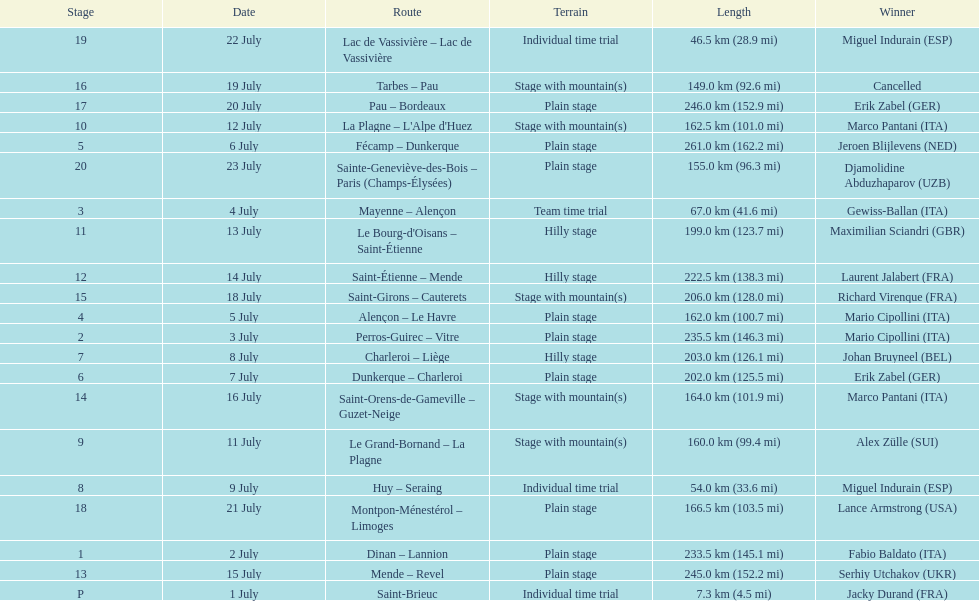How many routes have below 100 km total? 4. Parse the table in full. {'header': ['Stage', 'Date', 'Route', 'Terrain', 'Length', 'Winner'], 'rows': [['19', '22 July', 'Lac de Vassivière – Lac de Vassivière', 'Individual time trial', '46.5\xa0km (28.9\xa0mi)', 'Miguel Indurain\xa0(ESP)'], ['16', '19 July', 'Tarbes – Pau', 'Stage with mountain(s)', '149.0\xa0km (92.6\xa0mi)', 'Cancelled'], ['17', '20 July', 'Pau – Bordeaux', 'Plain stage', '246.0\xa0km (152.9\xa0mi)', 'Erik Zabel\xa0(GER)'], ['10', '12 July', "La Plagne – L'Alpe d'Huez", 'Stage with mountain(s)', '162.5\xa0km (101.0\xa0mi)', 'Marco Pantani\xa0(ITA)'], ['5', '6 July', 'Fécamp – Dunkerque', 'Plain stage', '261.0\xa0km (162.2\xa0mi)', 'Jeroen Blijlevens\xa0(NED)'], ['20', '23 July', 'Sainte-Geneviève-des-Bois – Paris (Champs-Élysées)', 'Plain stage', '155.0\xa0km (96.3\xa0mi)', 'Djamolidine Abduzhaparov\xa0(UZB)'], ['3', '4 July', 'Mayenne – Alençon', 'Team time trial', '67.0\xa0km (41.6\xa0mi)', 'Gewiss-Ballan\xa0(ITA)'], ['11', '13 July', "Le Bourg-d'Oisans – Saint-Étienne", 'Hilly stage', '199.0\xa0km (123.7\xa0mi)', 'Maximilian Sciandri\xa0(GBR)'], ['12', '14 July', 'Saint-Étienne – Mende', 'Hilly stage', '222.5\xa0km (138.3\xa0mi)', 'Laurent Jalabert\xa0(FRA)'], ['15', '18 July', 'Saint-Girons – Cauterets', 'Stage with mountain(s)', '206.0\xa0km (128.0\xa0mi)', 'Richard Virenque\xa0(FRA)'], ['4', '5 July', 'Alençon – Le Havre', 'Plain stage', '162.0\xa0km (100.7\xa0mi)', 'Mario Cipollini\xa0(ITA)'], ['2', '3 July', 'Perros-Guirec – Vitre', 'Plain stage', '235.5\xa0km (146.3\xa0mi)', 'Mario Cipollini\xa0(ITA)'], ['7', '8 July', 'Charleroi – Liège', 'Hilly stage', '203.0\xa0km (126.1\xa0mi)', 'Johan Bruyneel\xa0(BEL)'], ['6', '7 July', 'Dunkerque – Charleroi', 'Plain stage', '202.0\xa0km (125.5\xa0mi)', 'Erik Zabel\xa0(GER)'], ['14', '16 July', 'Saint-Orens-de-Gameville – Guzet-Neige', 'Stage with mountain(s)', '164.0\xa0km (101.9\xa0mi)', 'Marco Pantani\xa0(ITA)'], ['9', '11 July', 'Le Grand-Bornand – La Plagne', 'Stage with mountain(s)', '160.0\xa0km (99.4\xa0mi)', 'Alex Zülle\xa0(SUI)'], ['8', '9 July', 'Huy – Seraing', 'Individual time trial', '54.0\xa0km (33.6\xa0mi)', 'Miguel Indurain\xa0(ESP)'], ['18', '21 July', 'Montpon-Ménestérol – Limoges', 'Plain stage', '166.5\xa0km (103.5\xa0mi)', 'Lance Armstrong\xa0(USA)'], ['1', '2 July', 'Dinan – Lannion', 'Plain stage', '233.5\xa0km (145.1\xa0mi)', 'Fabio Baldato\xa0(ITA)'], ['13', '15 July', 'Mende – Revel', 'Plain stage', '245.0\xa0km (152.2\xa0mi)', 'Serhiy Utchakov\xa0(UKR)'], ['P', '1 July', 'Saint-Brieuc', 'Individual time trial', '7.3\xa0km (4.5\xa0mi)', 'Jacky Durand\xa0(FRA)']]} 